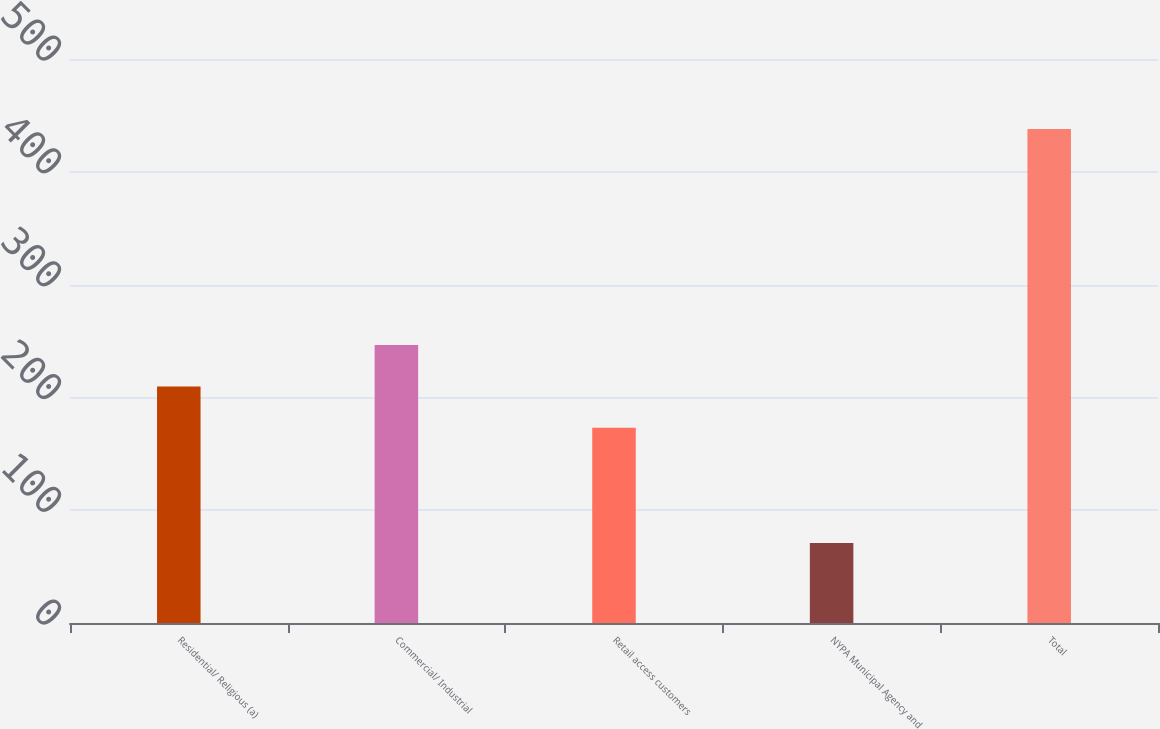Convert chart to OTSL. <chart><loc_0><loc_0><loc_500><loc_500><bar_chart><fcel>Residential/ Religious (a)<fcel>Commercial/ Industrial<fcel>Retail access customers<fcel>NYPA Municipal Agency and<fcel>Total<nl><fcel>209.7<fcel>246.4<fcel>173<fcel>71<fcel>438<nl></chart> 